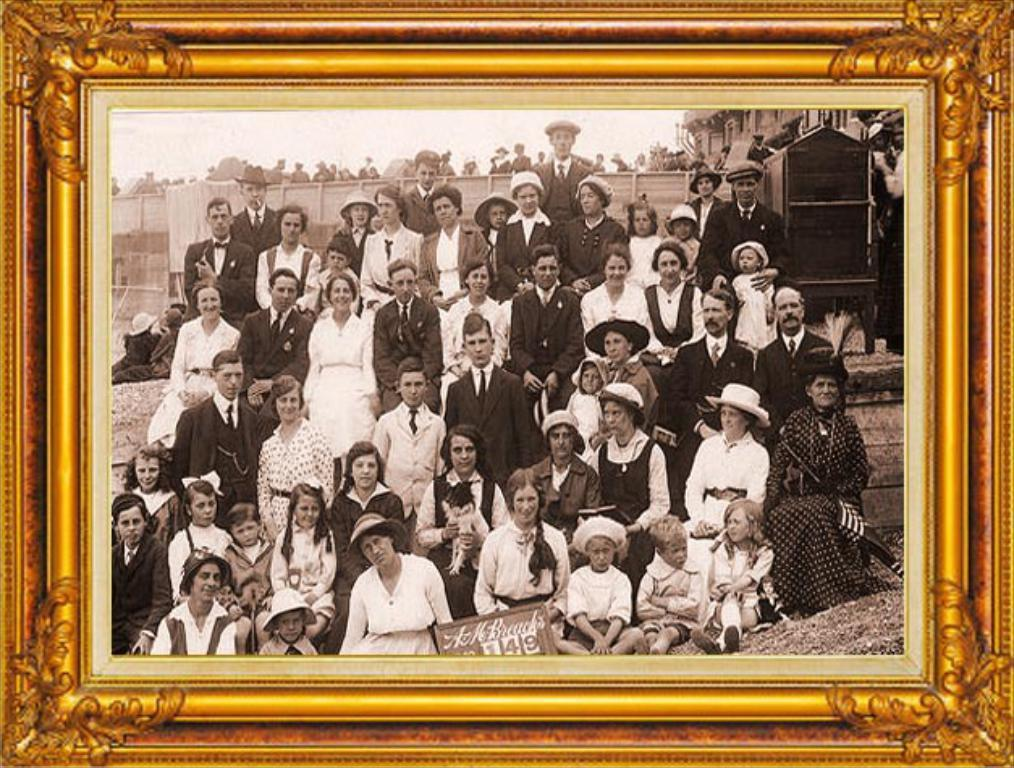What object is present in the image that typically holds a photo? There is a photo frame in the image. Who or what can be seen in the photo frame? There are people in the photo frame. What is visible behind the people in the photo frame? There is a fencing visible behind the people. Can you describe any other objects or features around the people in the photo frame? There are other unspecified things around the people, but their exact nature is not mentioned in the provided facts. What type of voice can be heard coming from the people in the photo frame? There is no voice present in the image, as it is a photo frame containing a still image of people. 